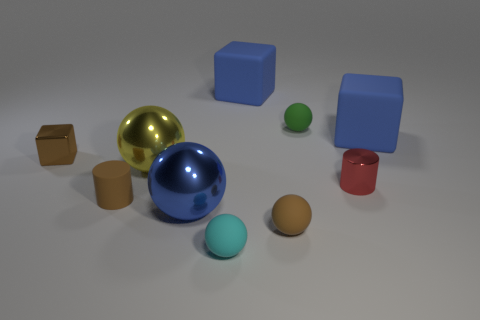What is the size of the other metallic thing that is the same shape as the large yellow thing?
Ensure brevity in your answer.  Large. There is a block that is in front of the green matte object and on the right side of the tiny matte cylinder; what size is it?
Make the answer very short. Large. There is a cylinder that is the same color as the tiny cube; what is its material?
Ensure brevity in your answer.  Rubber. There is a cyan ball that is made of the same material as the brown cylinder; what size is it?
Your answer should be very brief. Small. What is the color of the tiny cube that is made of the same material as the red thing?
Your response must be concise. Brown. Are there any rubber things of the same size as the yellow sphere?
Your answer should be compact. Yes. There is a green thing that is the same shape as the big yellow metallic object; what is its material?
Your answer should be compact. Rubber. What shape is the red thing that is the same size as the rubber cylinder?
Your answer should be compact. Cylinder. Is there another large object of the same shape as the yellow thing?
Offer a terse response. Yes. What shape is the matte object on the right side of the small metallic object that is on the right side of the metallic block?
Offer a terse response. Cube. 